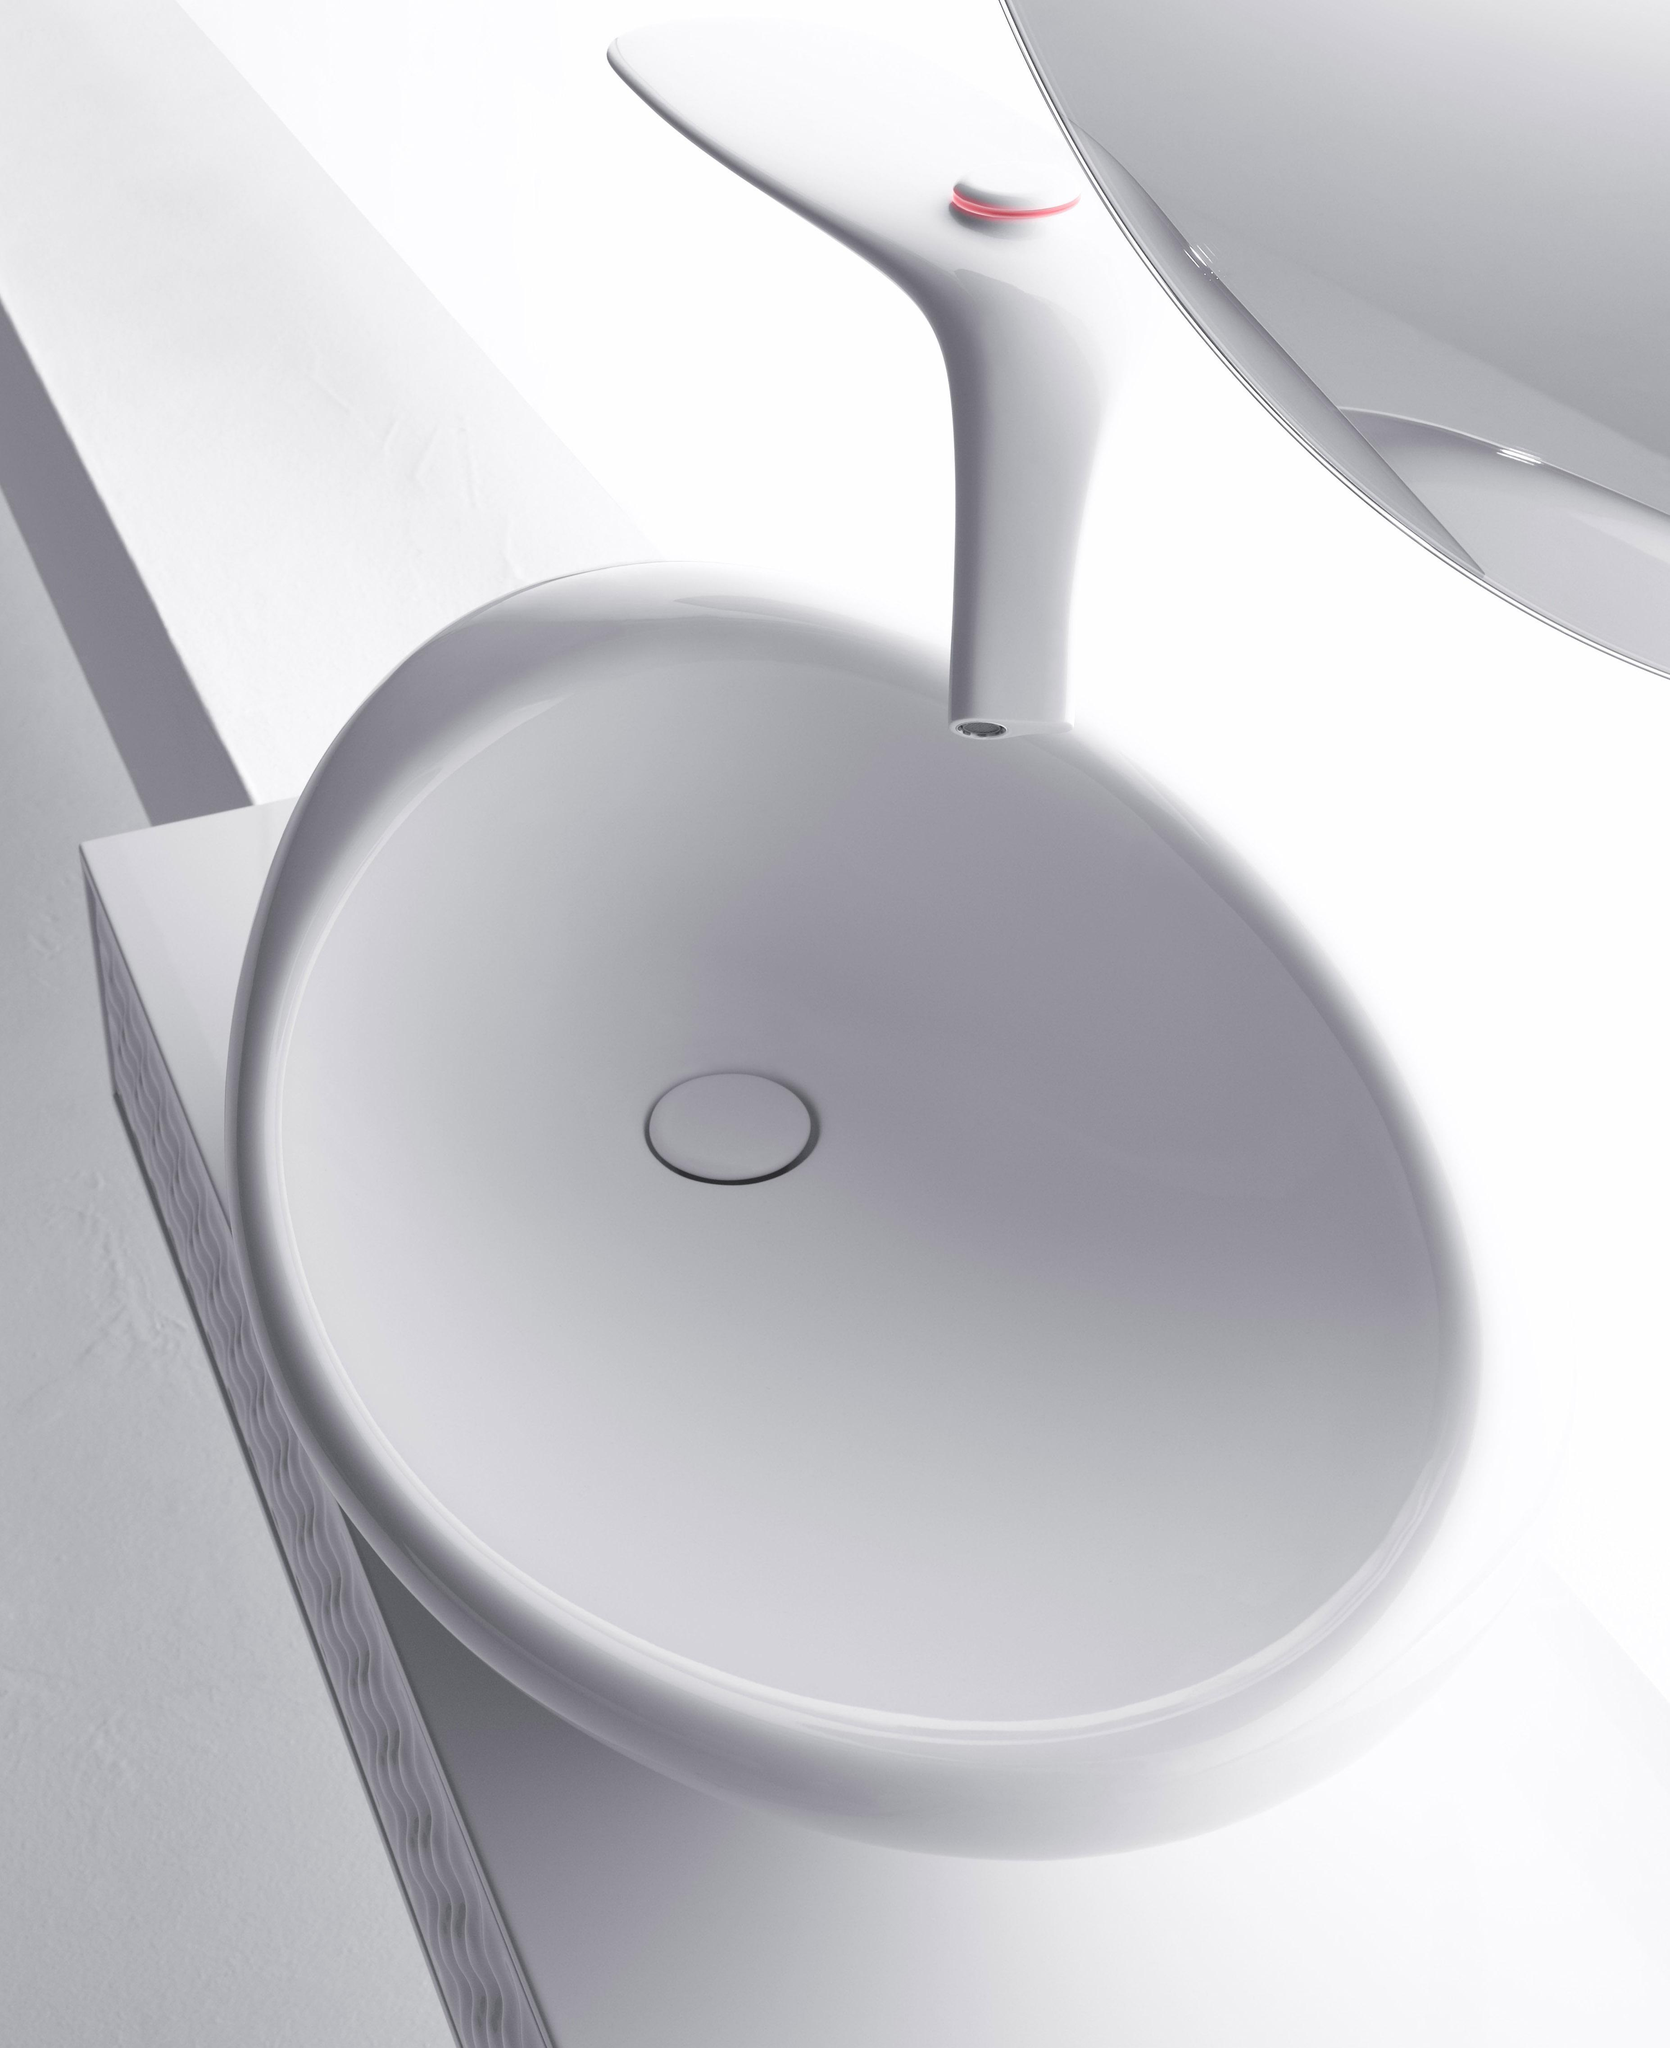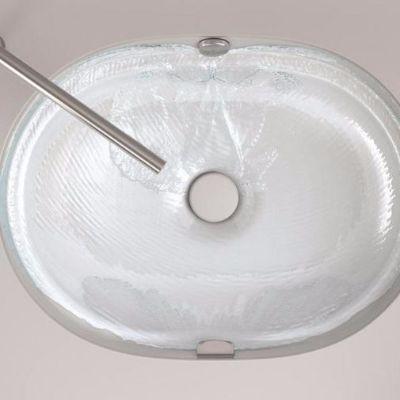The first image is the image on the left, the second image is the image on the right. Analyze the images presented: Is the assertion "the sinks is square in the right pic" valid? Answer yes or no. No. 